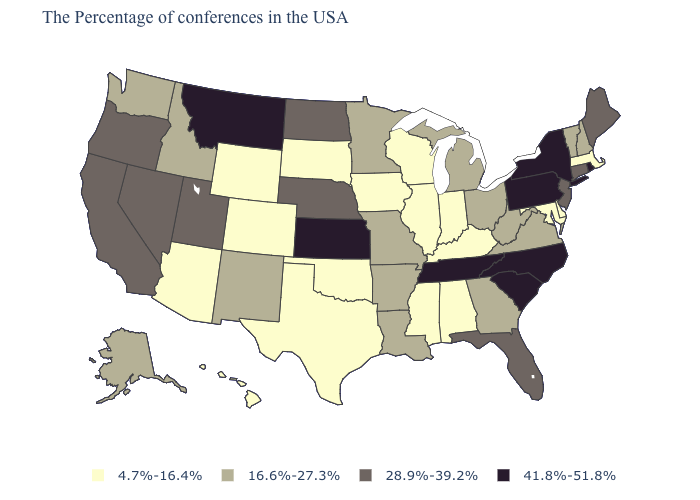Does Connecticut have the lowest value in the Northeast?
Short answer required. No. What is the value of Alabama?
Quick response, please. 4.7%-16.4%. What is the value of Texas?
Quick response, please. 4.7%-16.4%. Does Nebraska have the highest value in the MidWest?
Give a very brief answer. No. Which states hav the highest value in the West?
Give a very brief answer. Montana. Which states have the lowest value in the Northeast?
Keep it brief. Massachusetts. Does New York have the lowest value in the Northeast?
Write a very short answer. No. What is the value of North Dakota?
Answer briefly. 28.9%-39.2%. Name the states that have a value in the range 16.6%-27.3%?
Write a very short answer. New Hampshire, Vermont, Virginia, West Virginia, Ohio, Georgia, Michigan, Louisiana, Missouri, Arkansas, Minnesota, New Mexico, Idaho, Washington, Alaska. Does Connecticut have the highest value in the USA?
Answer briefly. No. What is the value of Arkansas?
Write a very short answer. 16.6%-27.3%. What is the lowest value in states that border Arizona?
Give a very brief answer. 4.7%-16.4%. Does Delaware have the lowest value in the South?
Short answer required. Yes. What is the value of Arizona?
Keep it brief. 4.7%-16.4%. What is the lowest value in the South?
Answer briefly. 4.7%-16.4%. 